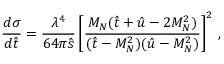Convert formula to latex. <formula><loc_0><loc_0><loc_500><loc_500>{ \frac { d \sigma } { d \hat { t } } } = { \frac { \lambda ^ { 4 } } { 6 4 \pi \hat { s } } } \left [ { \frac { M _ { N } ( \hat { t } + \hat { u } - 2 M _ { N } ^ { 2 } ) } { ( \hat { t } - M _ { N } ^ { 2 } ) ( \hat { u } - M _ { N } ^ { 2 } ) } } \right ] ^ { 2 } \, ,</formula> 